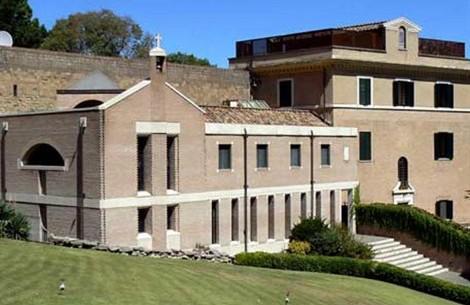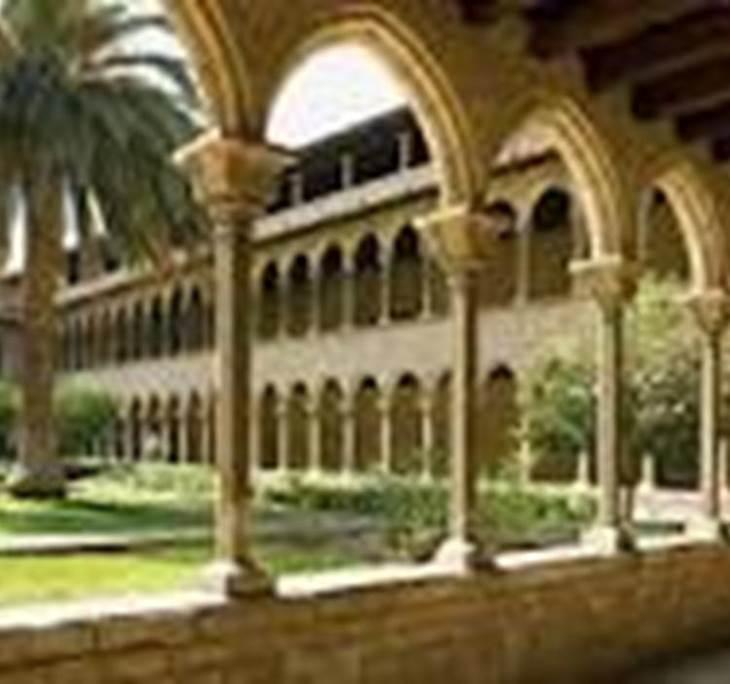The first image is the image on the left, the second image is the image on the right. Evaluate the accuracy of this statement regarding the images: "There are stairs in the image on the left.". Is it true? Answer yes or no. Yes. 